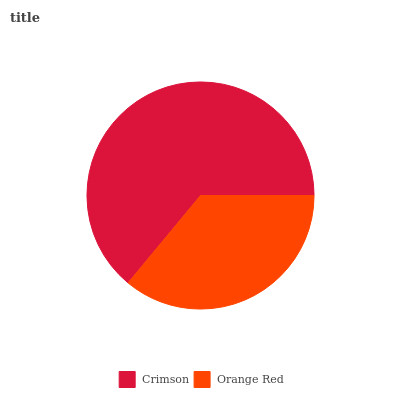Is Orange Red the minimum?
Answer yes or no. Yes. Is Crimson the maximum?
Answer yes or no. Yes. Is Orange Red the maximum?
Answer yes or no. No. Is Crimson greater than Orange Red?
Answer yes or no. Yes. Is Orange Red less than Crimson?
Answer yes or no. Yes. Is Orange Red greater than Crimson?
Answer yes or no. No. Is Crimson less than Orange Red?
Answer yes or no. No. Is Crimson the high median?
Answer yes or no. Yes. Is Orange Red the low median?
Answer yes or no. Yes. Is Orange Red the high median?
Answer yes or no. No. Is Crimson the low median?
Answer yes or no. No. 